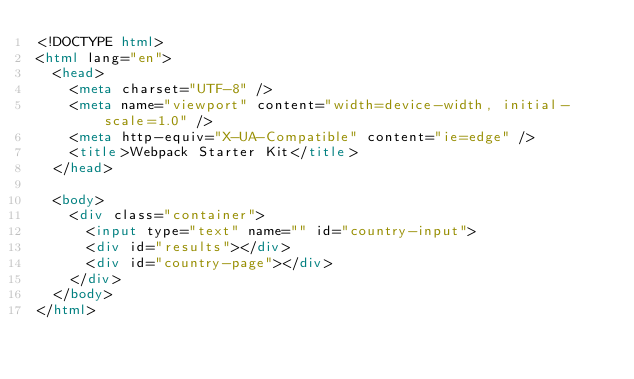<code> <loc_0><loc_0><loc_500><loc_500><_HTML_><!DOCTYPE html>
<html lang="en">
  <head>
    <meta charset="UTF-8" />
    <meta name="viewport" content="width=device-width, initial-scale=1.0" />
    <meta http-equiv="X-UA-Compatible" content="ie=edge" />
    <title>Webpack Starter Kit</title>
  </head>

  <body>
    <div class="container">
      <input type="text" name="" id="country-input">
      <div id="results"></div>
      <div id="country-page"></div>
    </div>
  </body>
</html>
</code> 